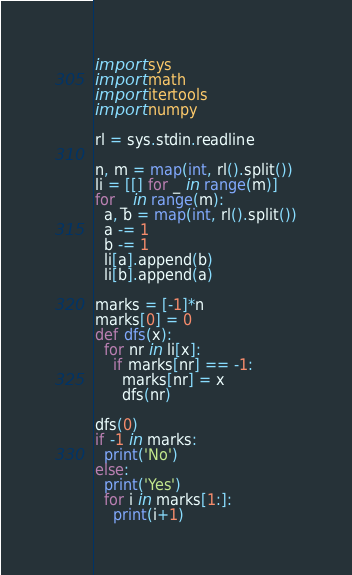Convert code to text. <code><loc_0><loc_0><loc_500><loc_500><_Python_>import sys
import math
import itertools
import numpy

rl = sys.stdin.readline

n, m = map(int, rl().split())
li = [[] for _ in range(m)]
for _ in range(m):
  a, b = map(int, rl().split())
  a -= 1
  b -= 1
  li[a].append(b)
  li[b].append(a)

marks = [-1]*n
marks[0] = 0
def dfs(x):
  for nr in li[x]:
    if marks[nr] == -1:
      marks[nr] = x
      dfs(nr)
  
dfs(0)
if -1 in marks:
  print('No')
else:
  print('Yes')
  for i in marks[1:]:
    print(i+1)
</code> 